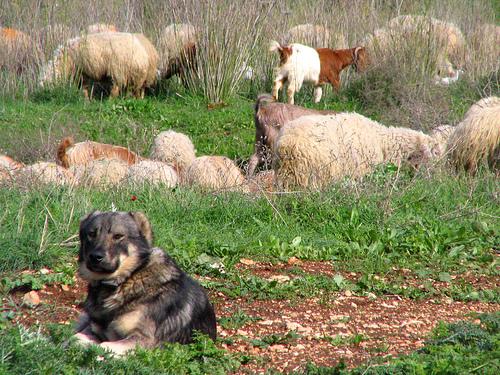Is the dog doing his job?
Concise answer only. Yes. Is the dog eating a sheep?
Answer briefly. No. Does there seem to be a wolf watching the sheep?
Keep it brief. No. 